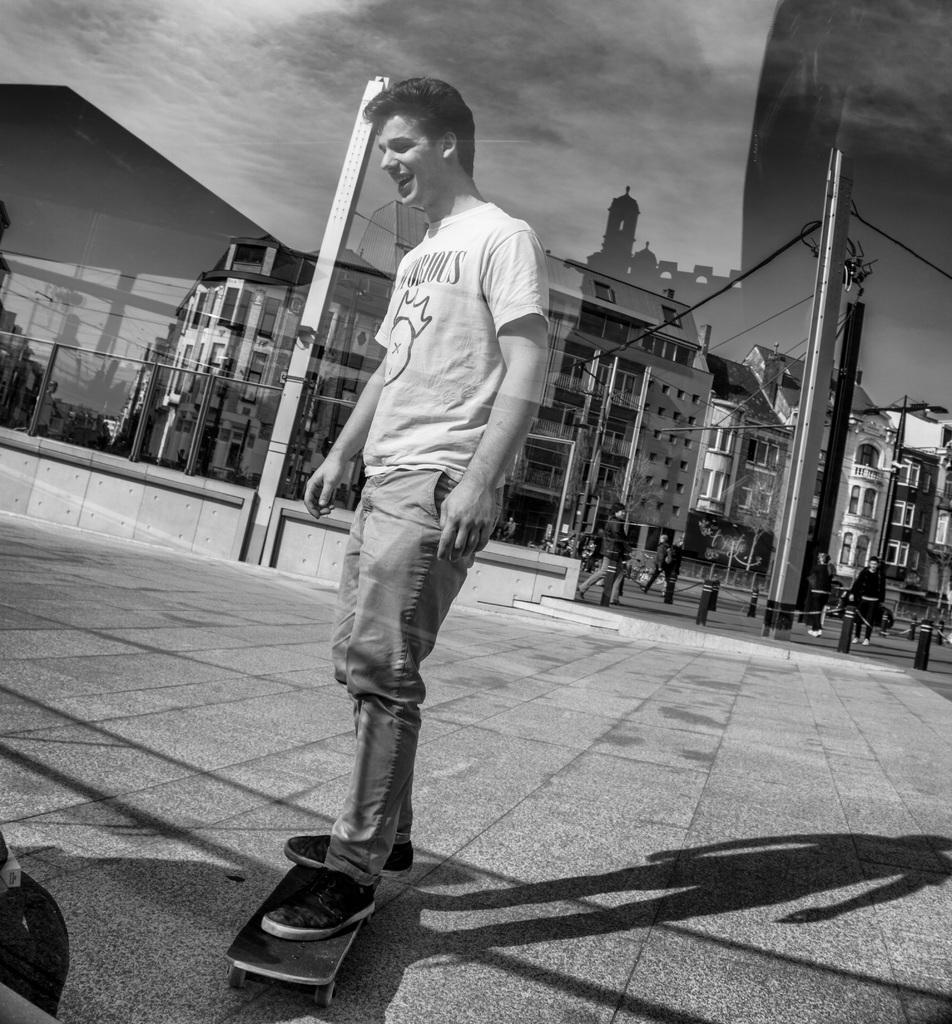How would you summarize this image in a sentence or two? In this image we can see many buildings. There is an electrical pole and few cables are connected to it. There is a cloudy sky in the image. There are few trees in the image. A man is standing on the skateboard. There is a reflection of buildings on the glasses. There are few people in the image. 